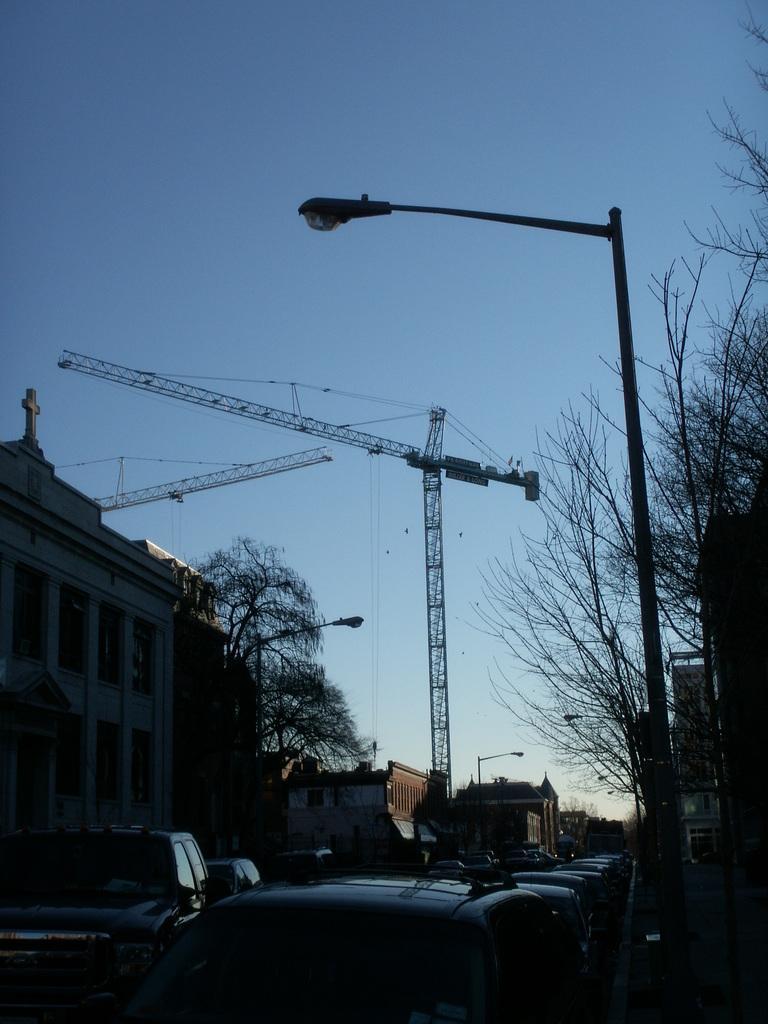Could you give a brief overview of what you see in this image? In this image there is a road at the bottom. On the road there are so many cars. On the left side there is a building. Beside the building there are cranes. On the right side there is a pole with the light on the footpath. Behind the pole there are trees. At the top there is the sky. 